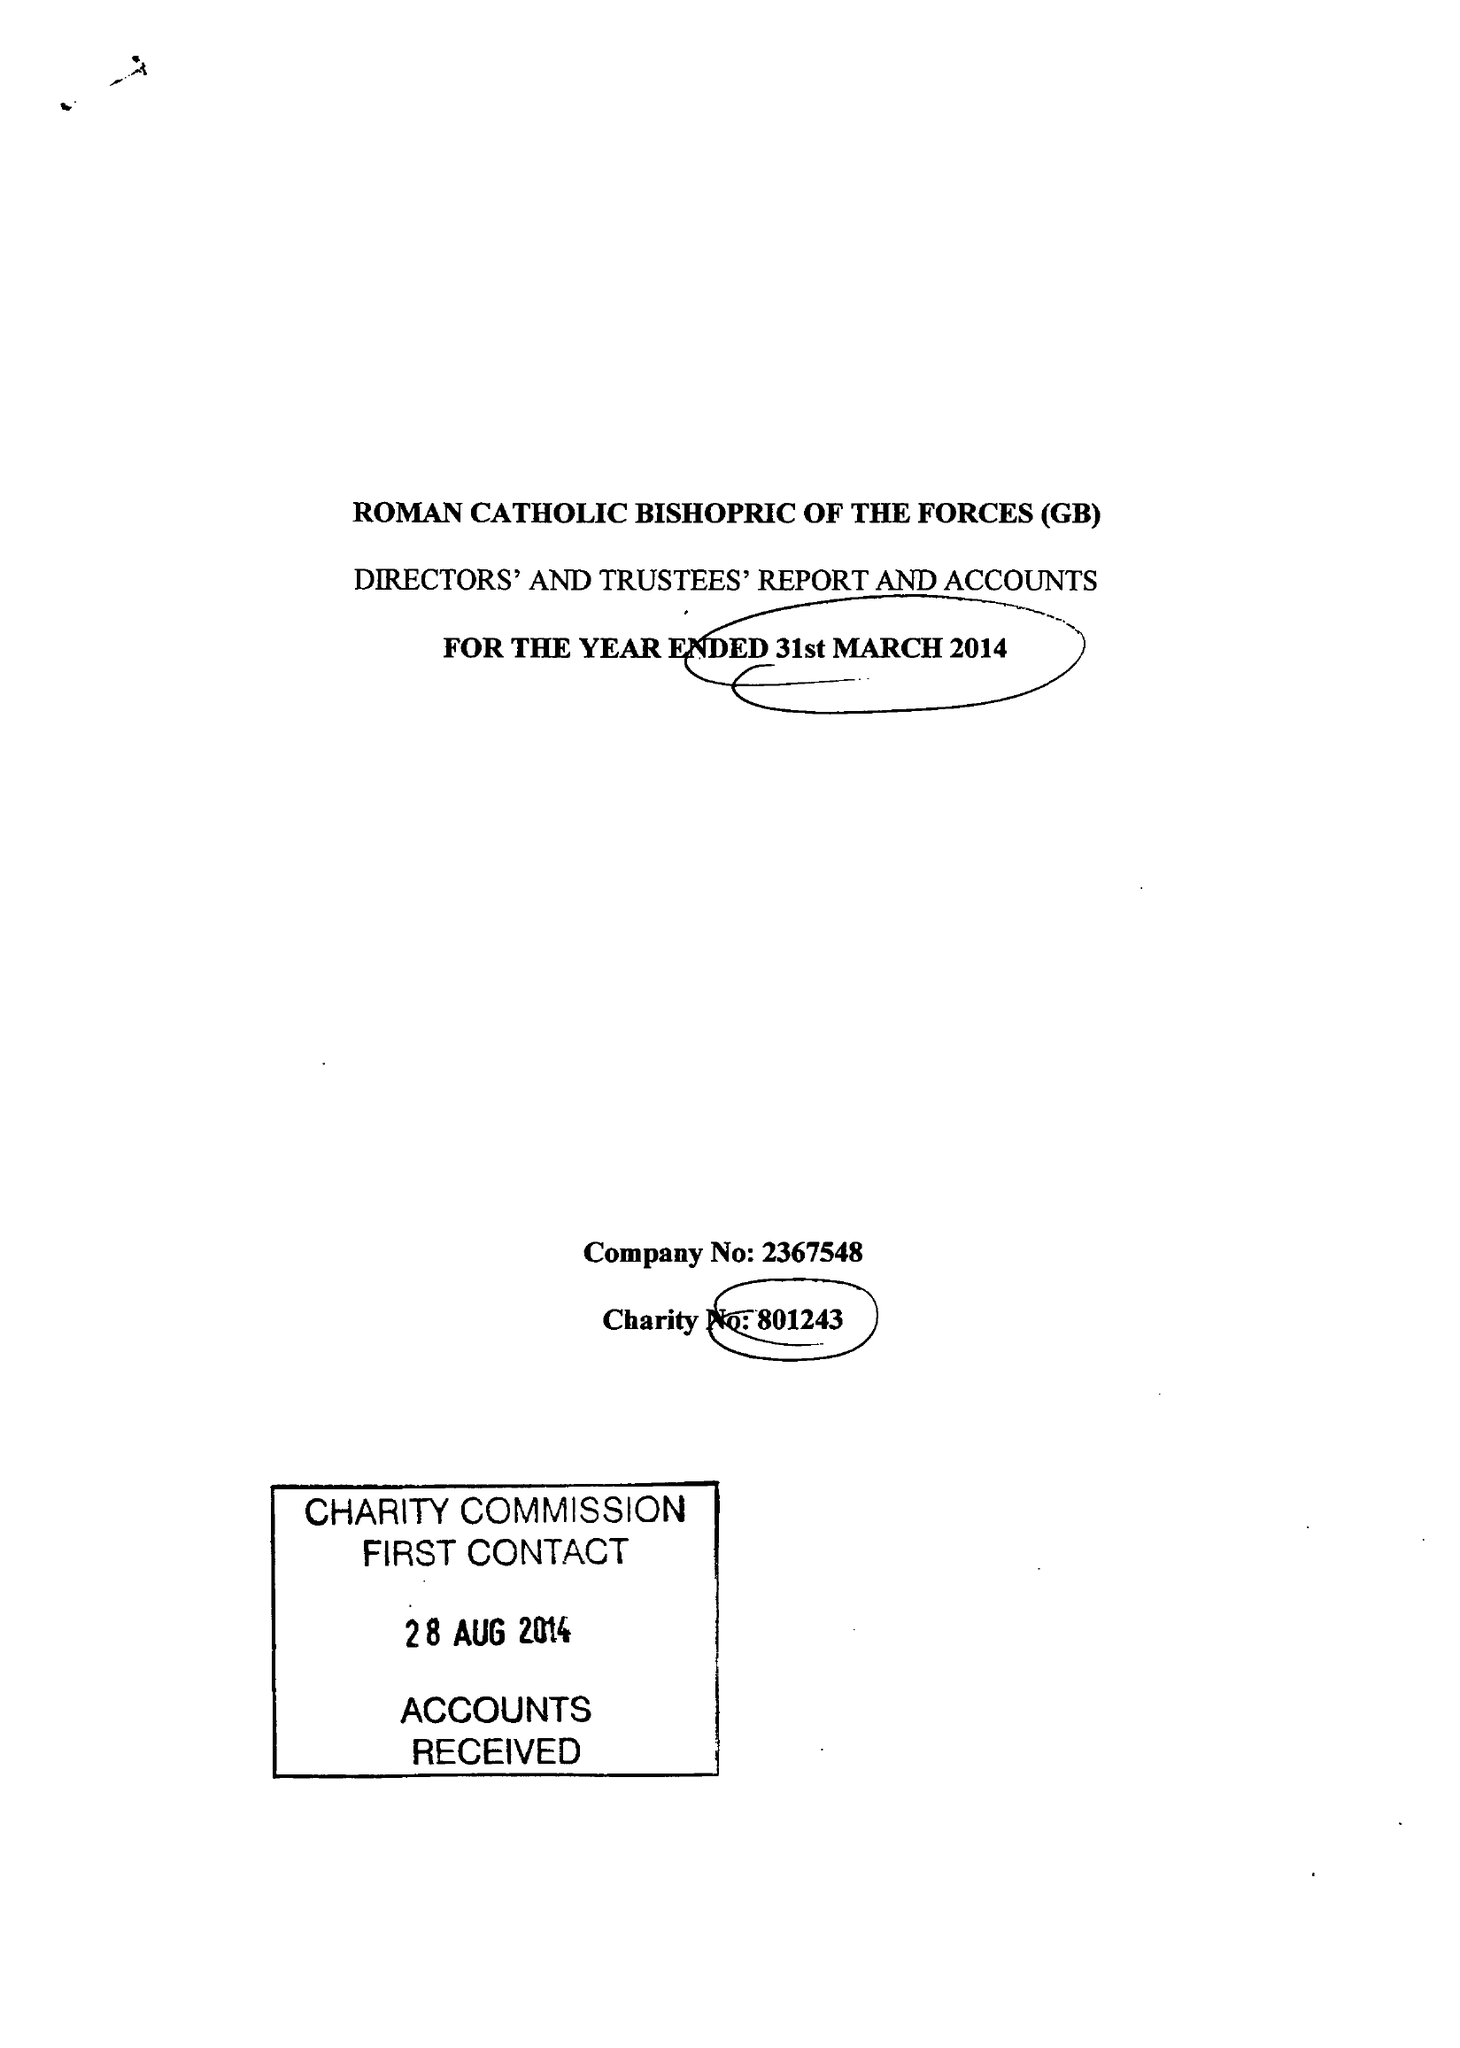What is the value for the address__postcode?
Answer the question using a single word or phrase. GU11 2BG 